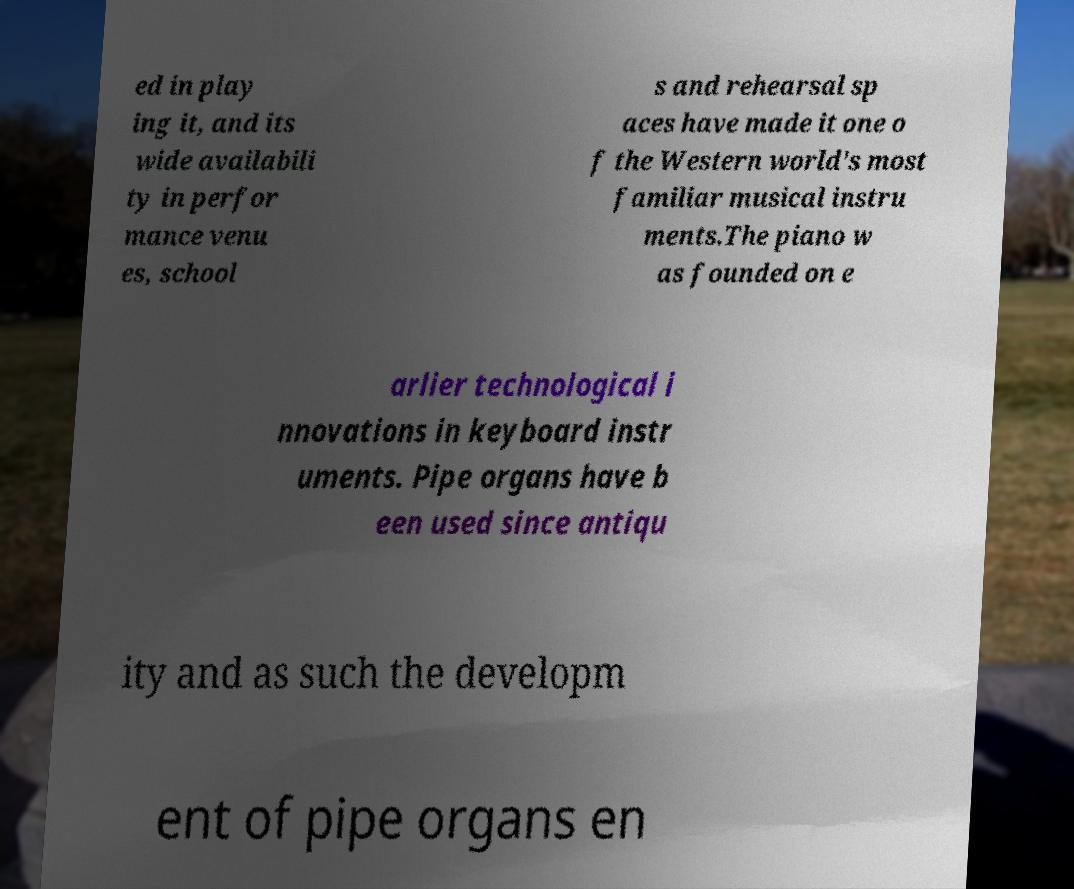There's text embedded in this image that I need extracted. Can you transcribe it verbatim? ed in play ing it, and its wide availabili ty in perfor mance venu es, school s and rehearsal sp aces have made it one o f the Western world's most familiar musical instru ments.The piano w as founded on e arlier technological i nnovations in keyboard instr uments. Pipe organs have b een used since antiqu ity and as such the developm ent of pipe organs en 